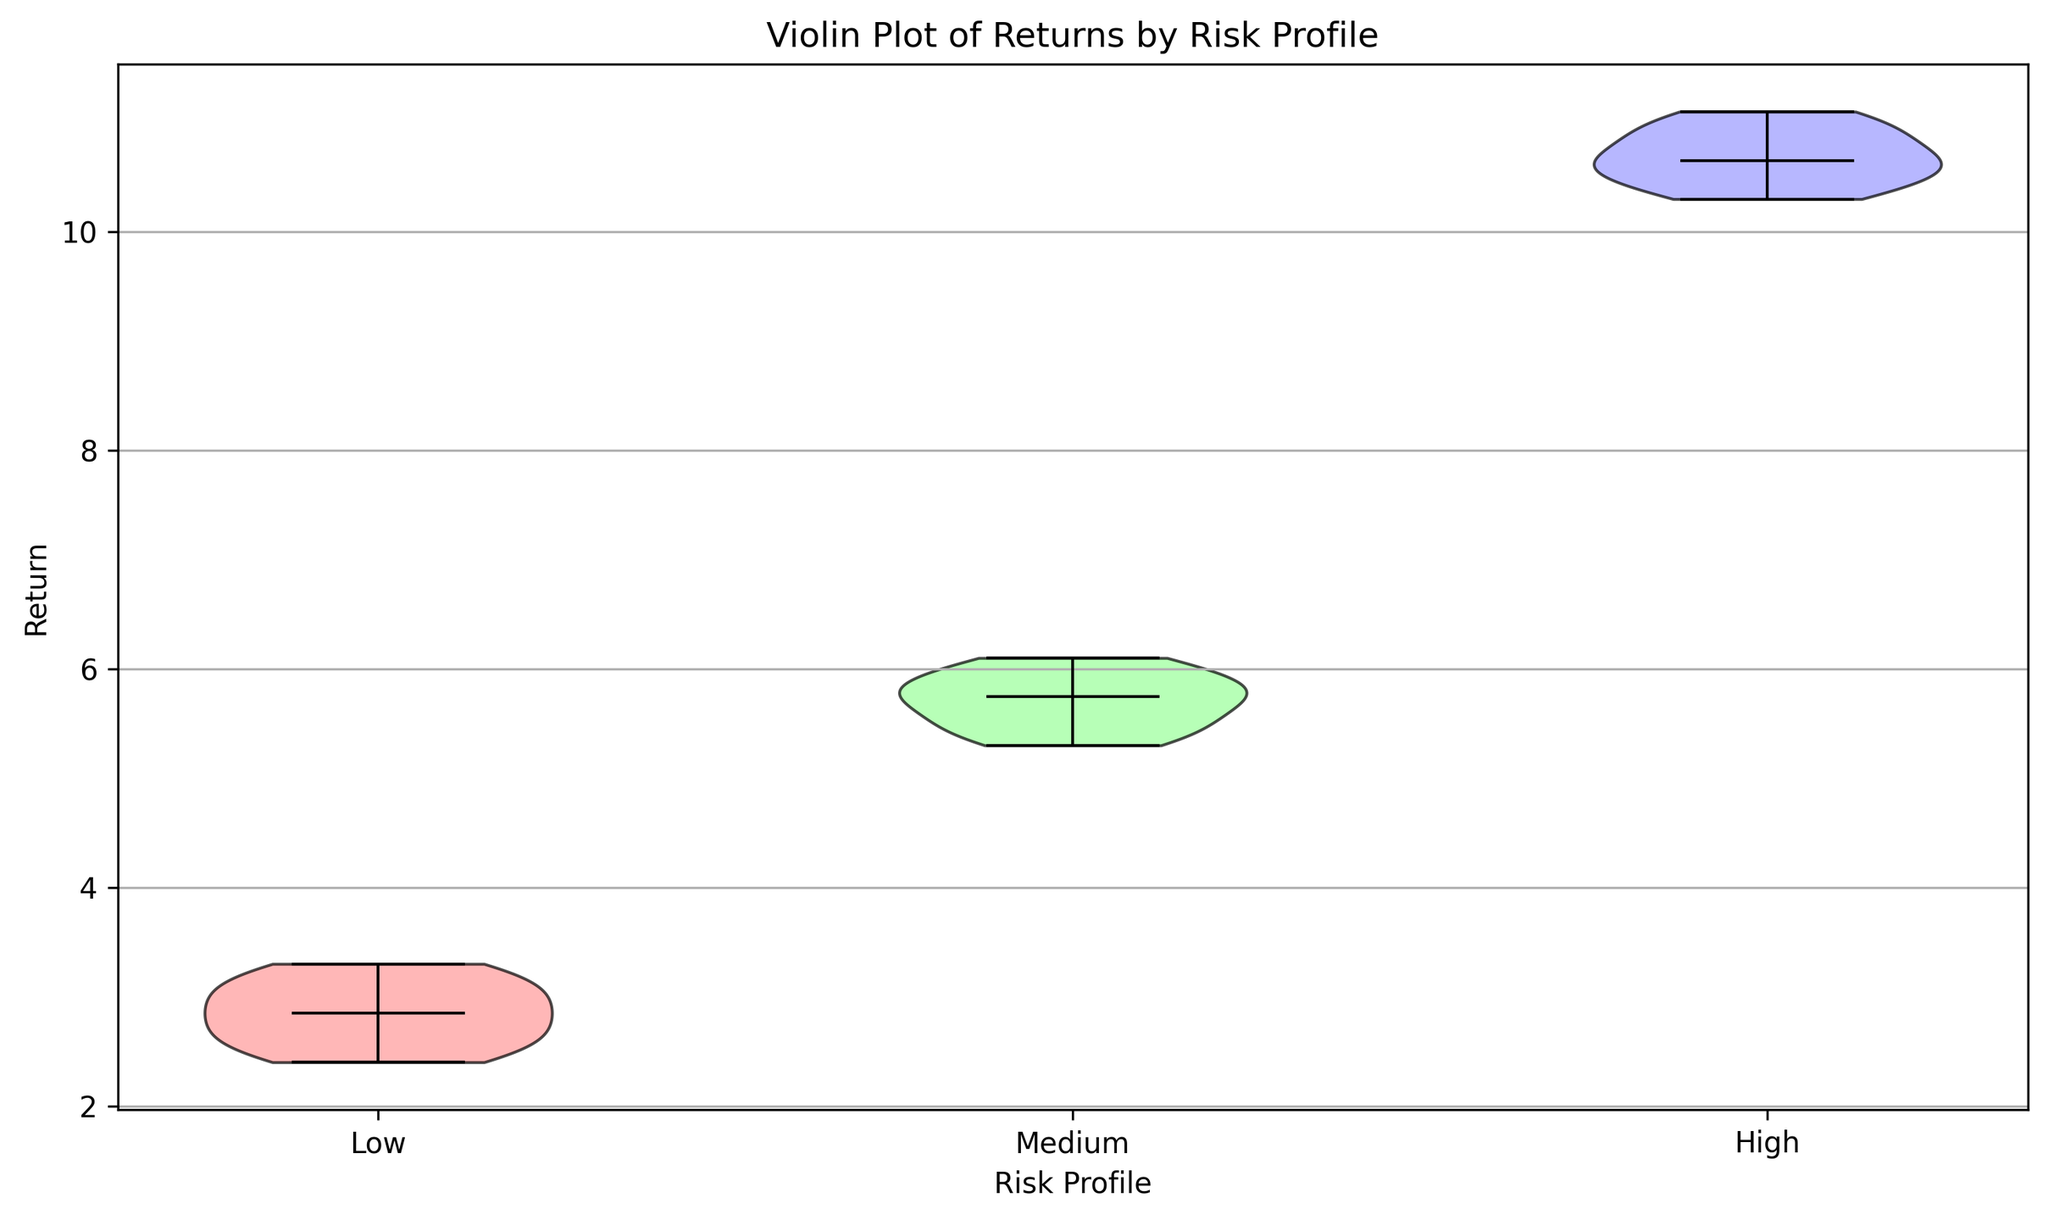What is the median return for the Low risk profile? The median return is indicated by a solid line within the violin plot for each risk profile. For the Low risk profile, you look at the position of this line within the Low risk profile's violin plot.
Answer: 2.85 Which risk profile shows the highest median return? Compare the positions of the median lines across the Low, Medium, and High risk profiles to see which one is highest. The High risk profile's median line is the highest among the three.
Answer: High How does the spread of returns differ between the Medium and High risk profiles? The spread of returns can be observed by the width and height of the violin plots. Comparing the plots, the High risk profile has a wider and taller plot, indicating a larger spread of returns compared to the Medium risk profile.
Answer: High is wider and taller What is the interquartile range (IQR) for the Medium risk profile? The IQR is the range between the first and third quartiles, which can be visually estimated from the thickest part of the violin plot, as it represents the middle 50% of the data. For the Medium risk profile, this part extends roughly from 5.5 to 6.0. The IQR can be computed as 6.0 - 5.5.
Answer: 0.5 Between which two risk profiles is the difference in median return the smallest? Examine the median lines' positions for the Low, Medium, and High risk profiles. The smallest difference in median return is between the Medium and High risk profiles.
Answer: Medium and High What color represents the Low risk profile in the violin plot? The color can be identified by looking at the shaded area of the Low risk profile's violin plot. It is shown in the leftmost section of the plot.
Answer: Red Which risk profile has the lowest observed return? Observe the lowest points on each of the violin plots for the Low, Medium, and High risk profiles. The Low risk profile has the lowest observed return.
Answer: Low Among the three risk profiles, which one has the most symmetrical distribution of returns? The symmetry of distribution can be seen by comparing the shapes of the violin plots. The Medium risk profile appears the most symmetrical, with similar spread on both sides of the median line.
Answer: Medium What is the median return difference between the Low and High risk profiles? To find the median return difference, look at the median lines for both the Low and High risk profiles. The Low risk profile median is at 2.85, and the High risk profile median is at 10.6. Subtracting these gives 10.6 - 2.85 = 7.75.
Answer: 7.75 